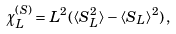Convert formula to latex. <formula><loc_0><loc_0><loc_500><loc_500>\chi ^ { ( S ) } _ { L } = L ^ { 2 } ( \langle S _ { L } ^ { 2 } \rangle - \langle S _ { L } \rangle ^ { 2 } ) \, ,</formula> 